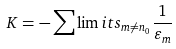<formula> <loc_0><loc_0><loc_500><loc_500>K = - \sum \lim i t s _ { m \not = n _ { 0 } } \frac { 1 } { \varepsilon _ { m } }</formula> 